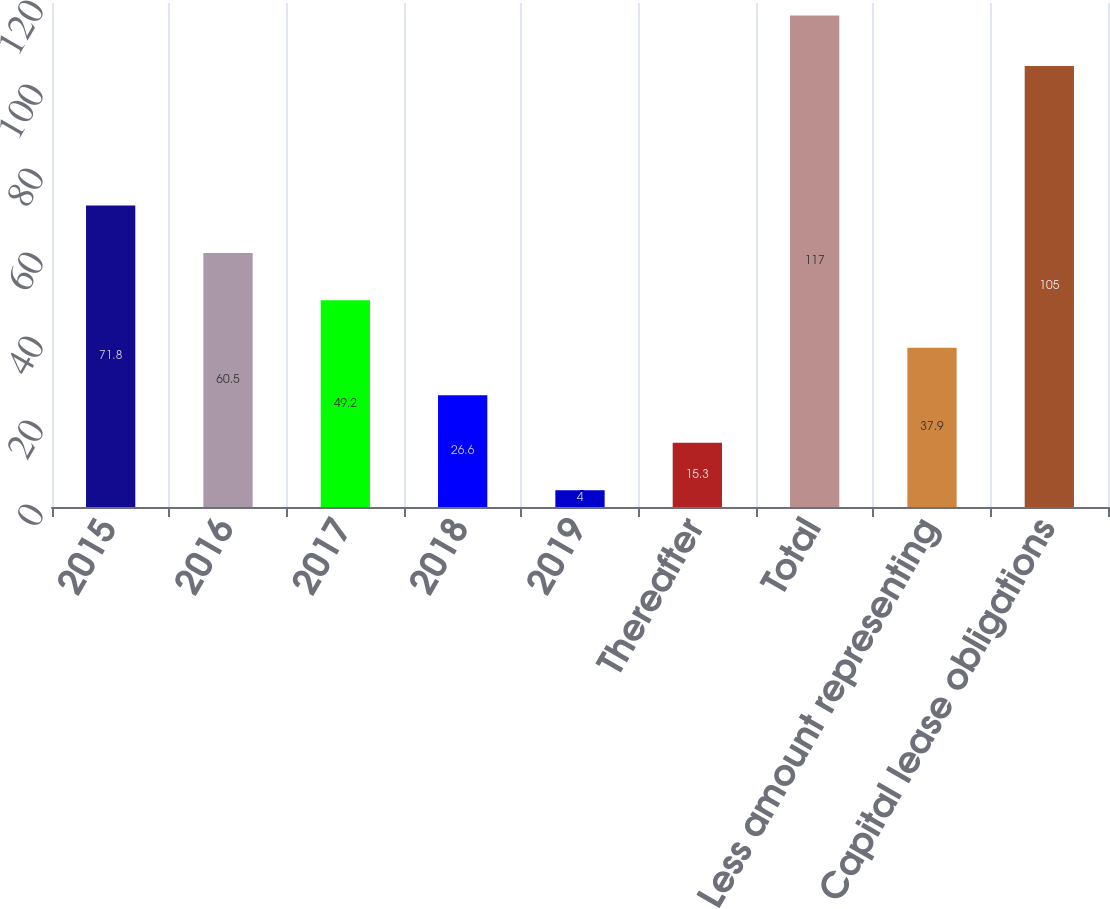Convert chart to OTSL. <chart><loc_0><loc_0><loc_500><loc_500><bar_chart><fcel>2015<fcel>2016<fcel>2017<fcel>2018<fcel>2019<fcel>Thereafter<fcel>Total<fcel>Less amount representing<fcel>Capital lease obligations<nl><fcel>71.8<fcel>60.5<fcel>49.2<fcel>26.6<fcel>4<fcel>15.3<fcel>117<fcel>37.9<fcel>105<nl></chart> 